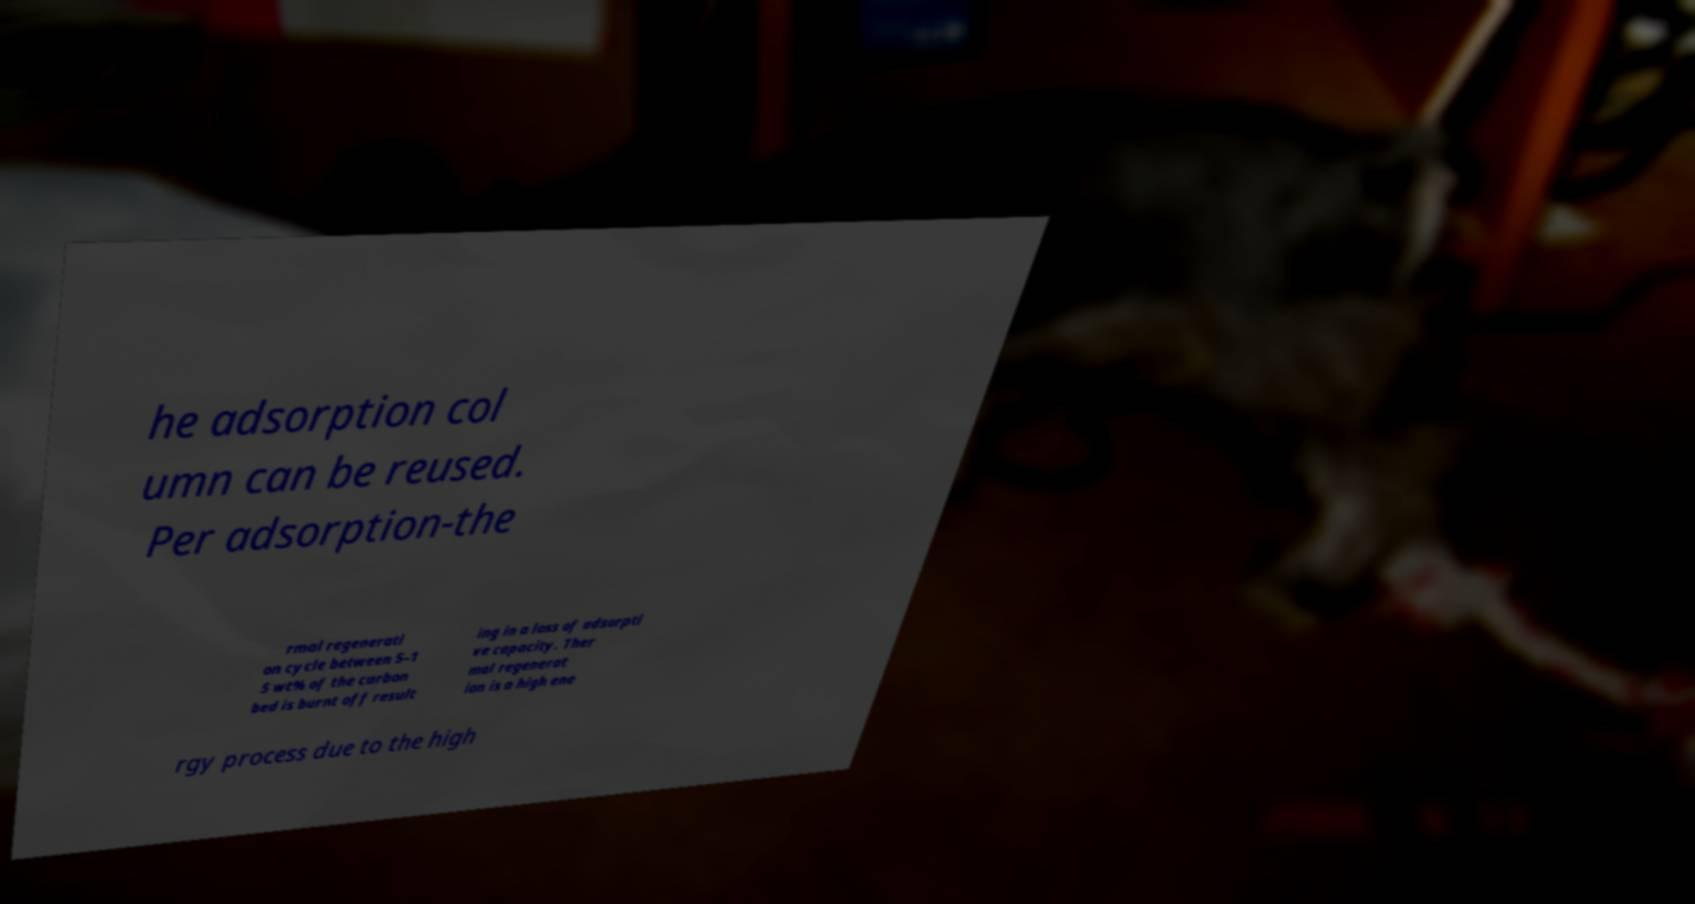Please identify and transcribe the text found in this image. he adsorption col umn can be reused. Per adsorption-the rmal regenerati on cycle between 5–1 5 wt% of the carbon bed is burnt off result ing in a loss of adsorpti ve capacity. Ther mal regenerat ion is a high ene rgy process due to the high 